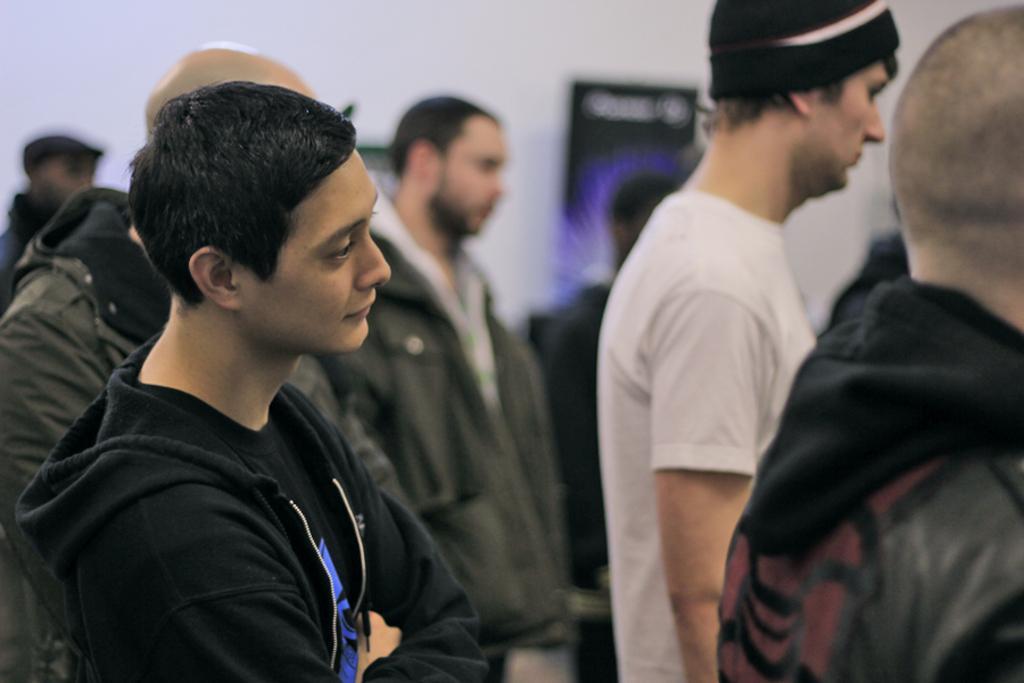Please provide a concise description of this image. In this image I can see the group of people standing. And these people are wearing the different color dresses. I can see one person with the black color hat. In the back I can see the wall and it is blurry. 